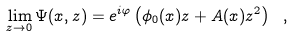<formula> <loc_0><loc_0><loc_500><loc_500>\lim _ { z \to 0 } \Psi ( x , z ) = e ^ { i \varphi } \left ( \phi _ { 0 } ( x ) z + A ( x ) z ^ { 2 } \right ) \ ,</formula> 